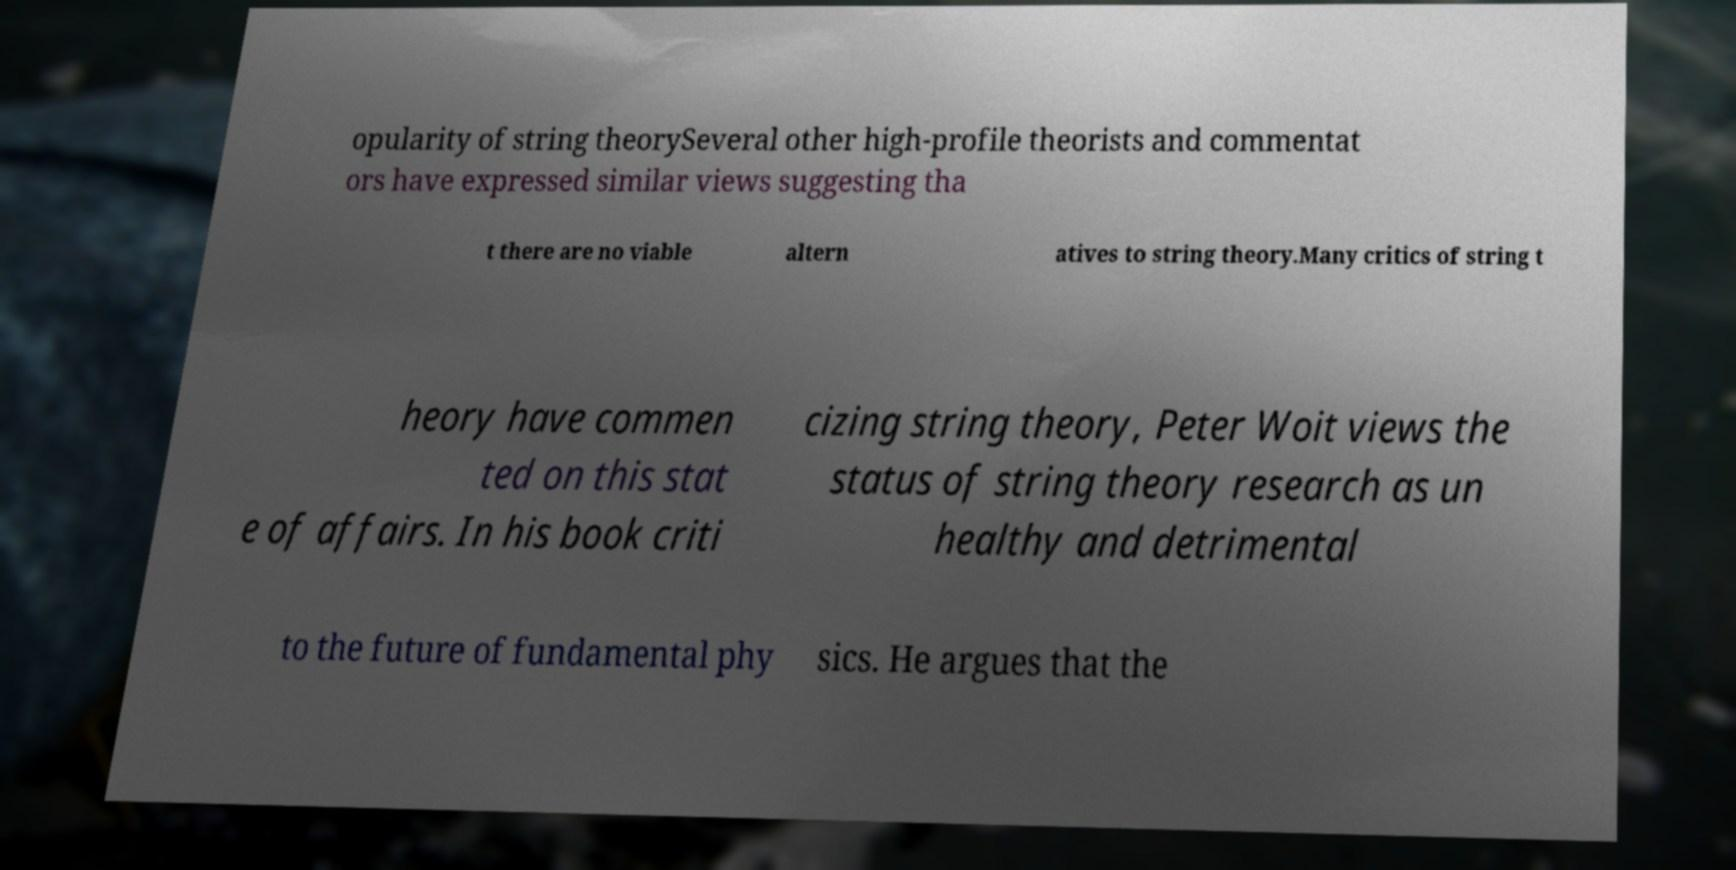What messages or text are displayed in this image? I need them in a readable, typed format. opularity of string theorySeveral other high-profile theorists and commentat ors have expressed similar views suggesting tha t there are no viable altern atives to string theory.Many critics of string t heory have commen ted on this stat e of affairs. In his book criti cizing string theory, Peter Woit views the status of string theory research as un healthy and detrimental to the future of fundamental phy sics. He argues that the 